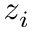Convert formula to latex. <formula><loc_0><loc_0><loc_500><loc_500>z _ { i }</formula> 